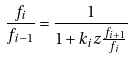<formula> <loc_0><loc_0><loc_500><loc_500>\frac { f _ { i } } { f _ { i - 1 } } = \frac { 1 } { 1 + k _ { i } z \frac { f _ { i + 1 } } { f _ { i } } }</formula> 